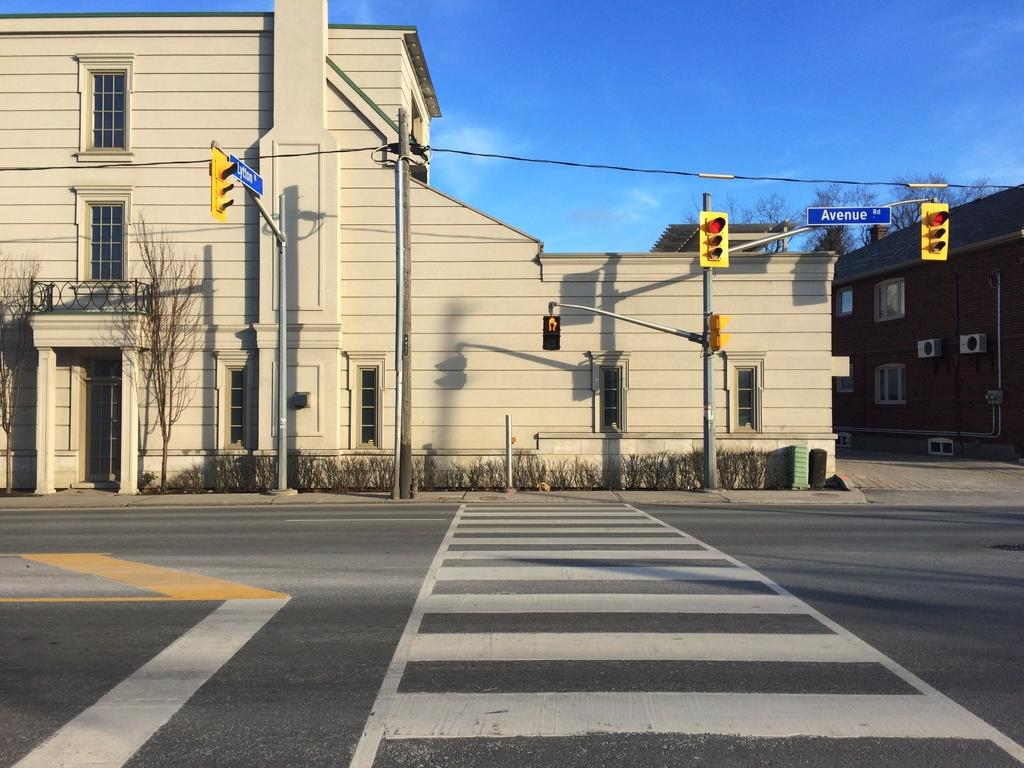<image>
Write a terse but informative summary of the picture. The cross walk to a street with a sign for Avenue road next to it. 